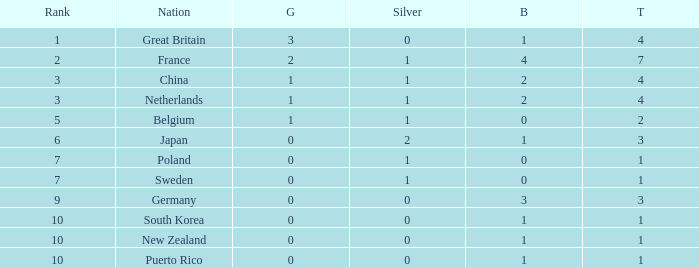What is the total where the gold is larger than 2? 1.0. 